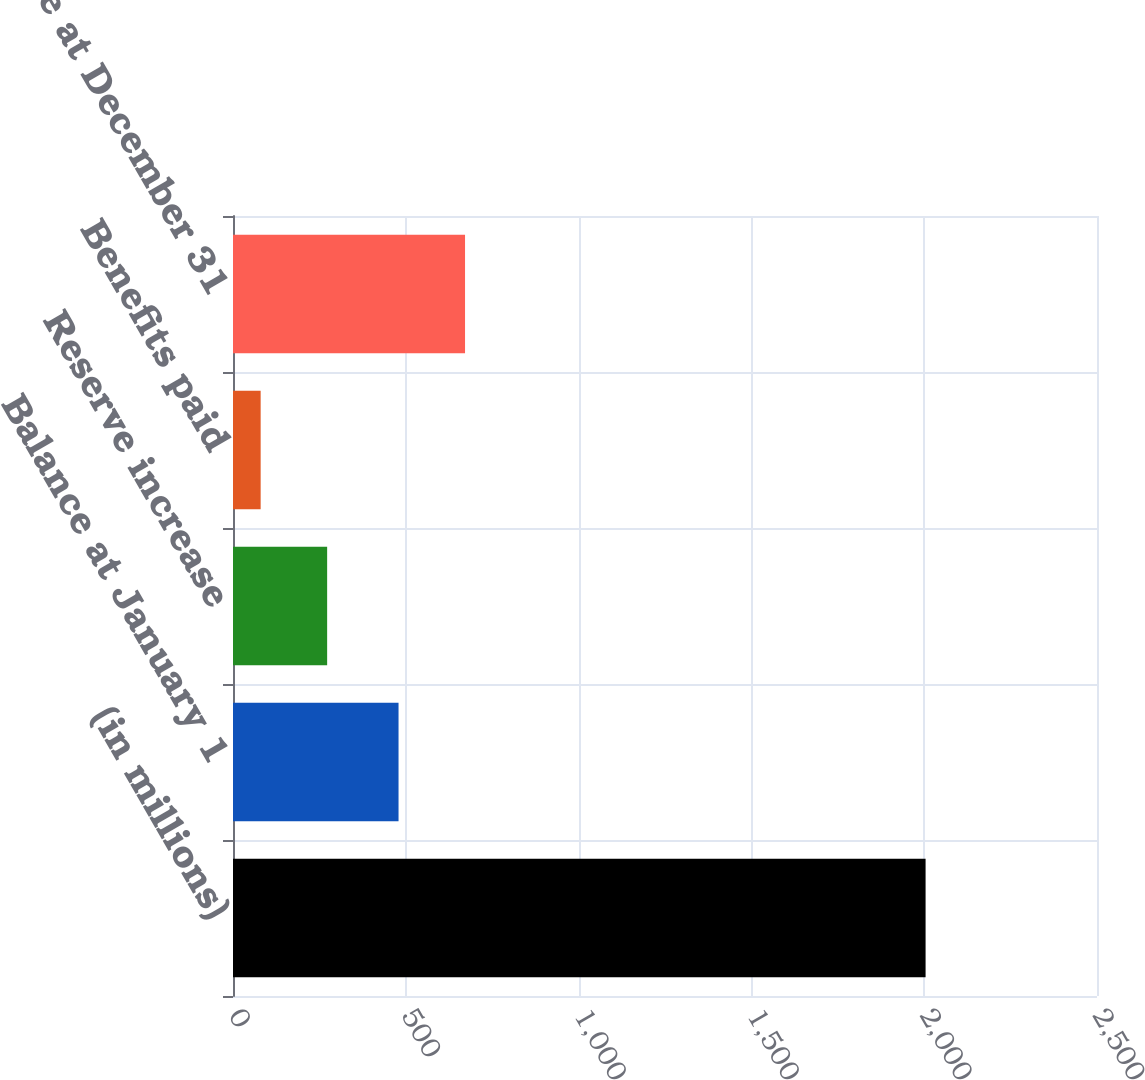<chart> <loc_0><loc_0><loc_500><loc_500><bar_chart><fcel>(in millions)<fcel>Balance at January 1<fcel>Reserve increase<fcel>Benefits paid<fcel>Balance at December 31<nl><fcel>2004<fcel>479<fcel>272.4<fcel>80<fcel>671.4<nl></chart> 